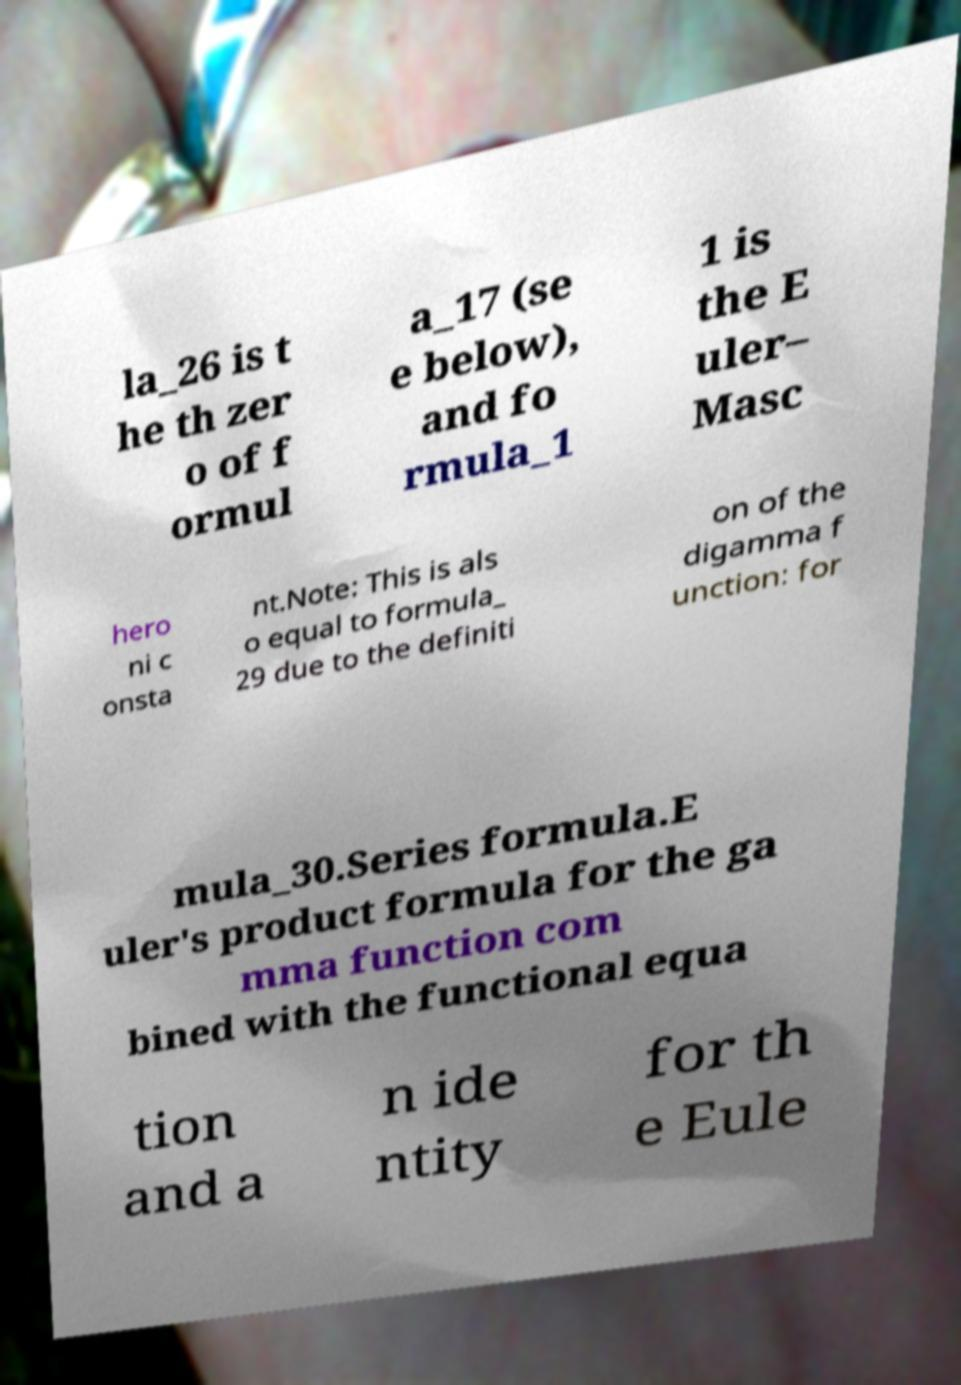Can you accurately transcribe the text from the provided image for me? la_26 is t he th zer o of f ormul a_17 (se e below), and fo rmula_1 1 is the E uler– Masc hero ni c onsta nt.Note: This is als o equal to formula_ 29 due to the definiti on of the digamma f unction: for mula_30.Series formula.E uler's product formula for the ga mma function com bined with the functional equa tion and a n ide ntity for th e Eule 